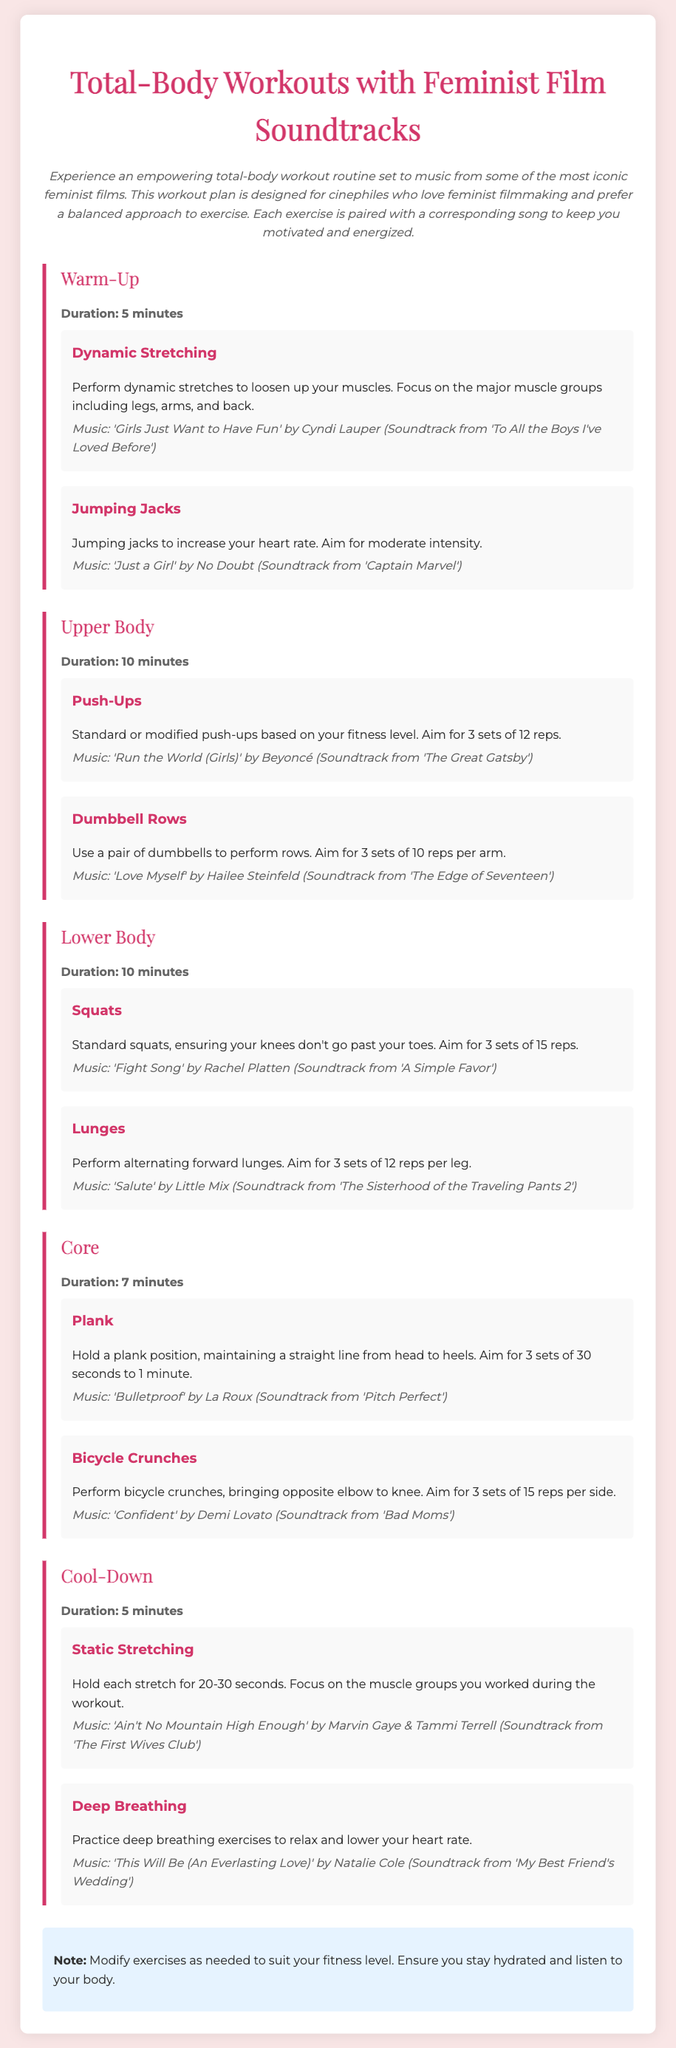What is the duration of the warm-up? The warm-up section specifies a duration of 5 minutes.
Answer: 5 minutes Which song is used for Jumping Jacks? The document mentions 'Just a Girl' by No Doubt for Jumping Jacks.
Answer: Just a Girl How many sets of Push-Ups should be performed? The document instructs to aim for 3 sets of 12 reps for Push-Ups.
Answer: 3 sets of 12 reps What type of lunges are recommended? The workout plan suggests performing alternating forward lunges.
Answer: Alternating forward lunges Which exercise targets the core? Plank is listed as an exercise that targets the core.
Answer: Plank What is the duration for the cool-down section? The cool-down section indicates a duration of 5 minutes.
Answer: 5 minutes Which song is recommended for Cool-Down Deep Breathing? The music for Deep Breathing is 'This Will Be (An Everlasting Love)' by Natalie Cole.
Answer: This Will Be (An Everlasting Love) What should you focus on during Static Stretching? The workout plan states to focus on the muscle groups you worked during the workout.
Answer: Muscle groups worked during the workout What is the main theme of the music playlists in this workout? The music playlists are from iconic feminist films.
Answer: Feminist films 